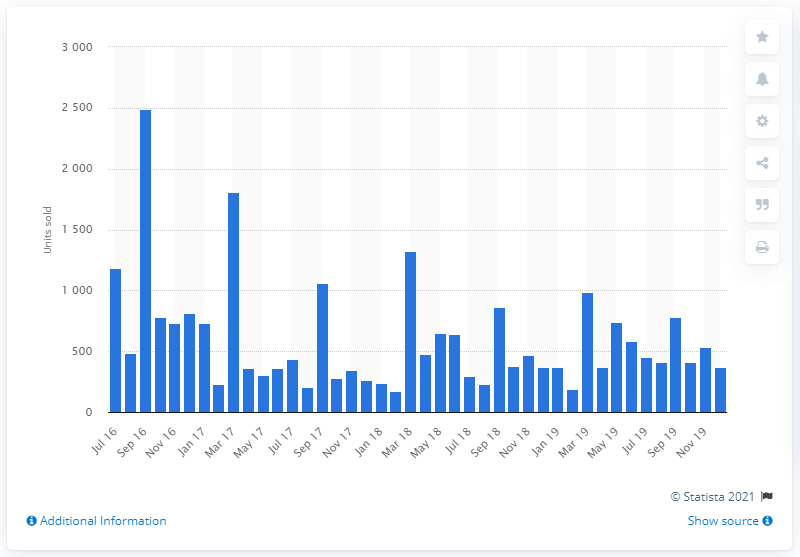Indicate a few pertinent items in this graphic. During the period of August to November 2019, a total of 411 new Jeep cars were sold. 